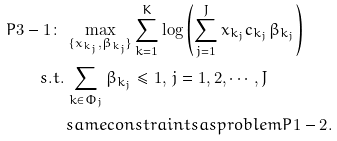Convert formula to latex. <formula><loc_0><loc_0><loc_500><loc_500>P 3 - 1 \colon & \, \max _ { \{ x _ { k _ { j } } , \beta _ { k _ { j } } \} } \sum _ { k = 1 } ^ { K } { \log \left ( \sum _ { j = 1 } ^ { J } x _ { k _ { j } } c _ { k _ { j } } \beta _ { k _ { j } } \right ) } \\ s . t . & \, \sum _ { k \in \Phi _ { j } } \beta _ { k _ { j } } \leq 1 , \, j = 1 , 2 , \cdots , J \\ & \, s a m e c o n s t r a i n t s a s p r o b l e m { P 1 - 2 } .</formula> 